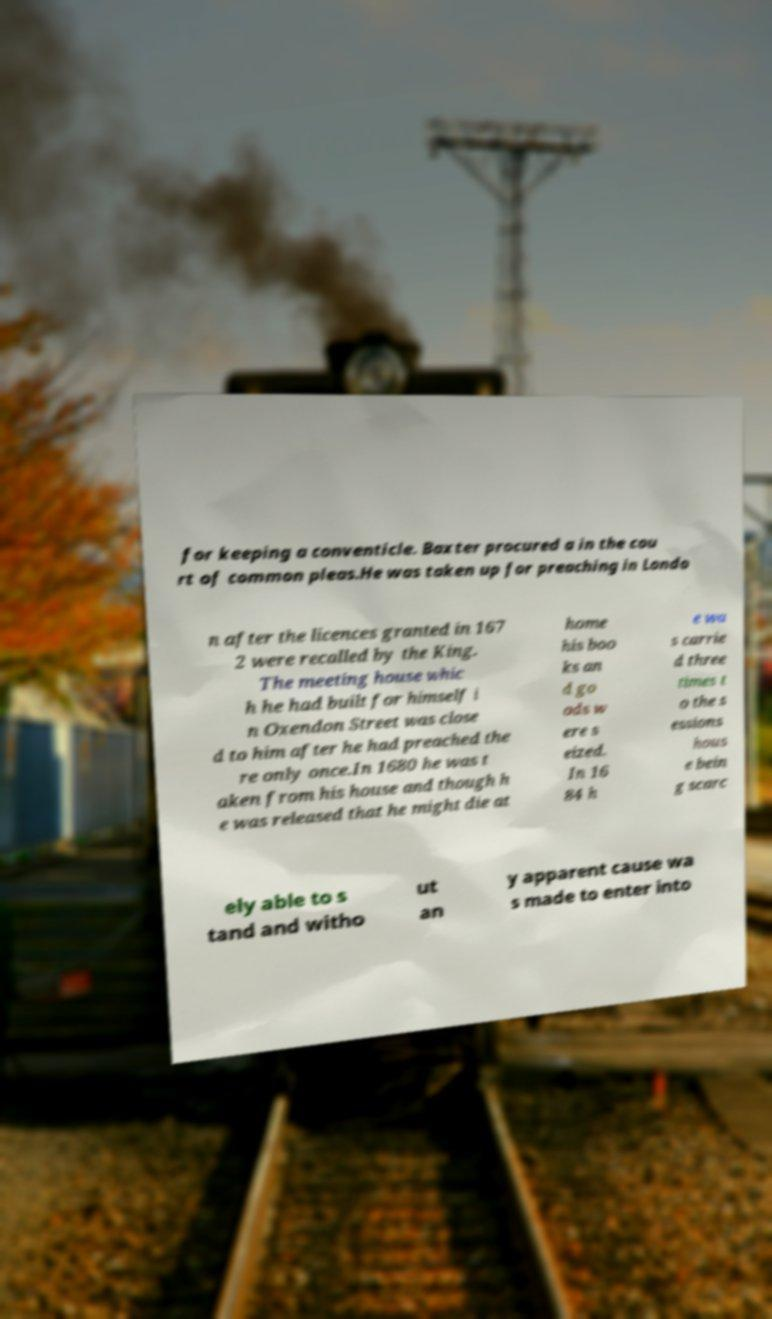Can you read and provide the text displayed in the image?This photo seems to have some interesting text. Can you extract and type it out for me? for keeping a conventicle. Baxter procured a in the cou rt of common pleas.He was taken up for preaching in Londo n after the licences granted in 167 2 were recalled by the King. The meeting house whic h he had built for himself i n Oxendon Street was close d to him after he had preached the re only once.In 1680 he was t aken from his house and though h e was released that he might die at home his boo ks an d go ods w ere s eized. In 16 84 h e wa s carrie d three times t o the s essions hous e bein g scarc ely able to s tand and witho ut an y apparent cause wa s made to enter into 